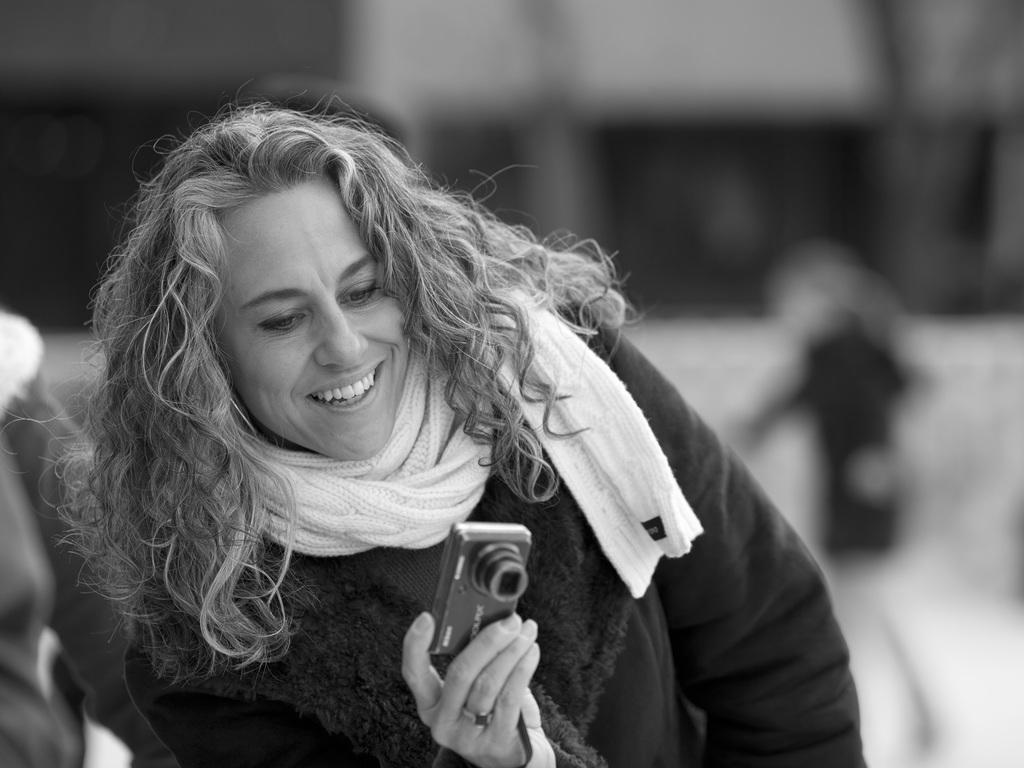What is the main subject of the image? The main subject of the image is a woman. What is the woman wearing in the image? The woman is wearing a black dress. What is the woman holding in her right hand? The woman is holding a camera in her right hand. Can you tell me how many sheep are present in the image? There are no sheep present in the image; it features a woman wearing a black dress and holding a camera. What is the woman's belief about the distance between the Earth and the Moon? There is no information about the woman's beliefs in the image. 